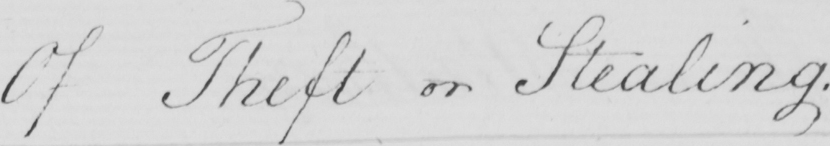Can you tell me what this handwritten text says? Of Theft or Stealing . 